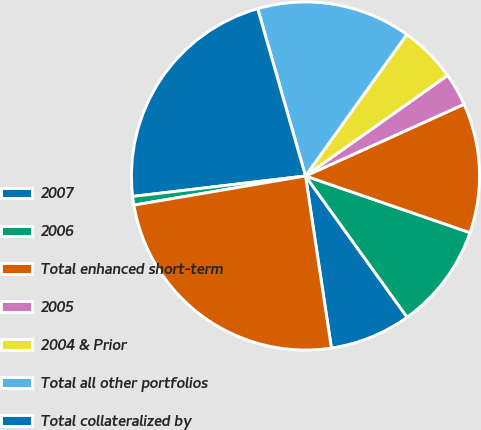<chart> <loc_0><loc_0><loc_500><loc_500><pie_chart><fcel>2007<fcel>2006<fcel>Total enhanced short-term<fcel>2005<fcel>2004 & Prior<fcel>Total all other portfolios<fcel>Total collateralized by<fcel>Other asset-backed<fcel>Total asset-backed<nl><fcel>7.55%<fcel>9.79%<fcel>12.04%<fcel>3.05%<fcel>5.3%<fcel>14.32%<fcel>22.45%<fcel>0.8%<fcel>24.7%<nl></chart> 